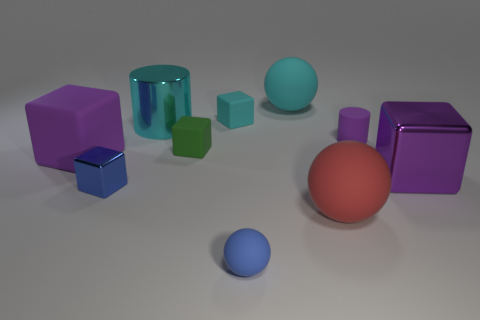Subtract all green blocks. How many blocks are left? 4 Subtract all purple metallic blocks. How many blocks are left? 4 Subtract all yellow blocks. Subtract all gray balls. How many blocks are left? 5 Subtract all cylinders. How many objects are left? 8 Add 6 big gray metallic balls. How many big gray metallic balls exist? 6 Subtract 0 red cubes. How many objects are left? 10 Subtract all tiny cylinders. Subtract all tiny blue rubber balls. How many objects are left? 8 Add 3 large rubber balls. How many large rubber balls are left? 5 